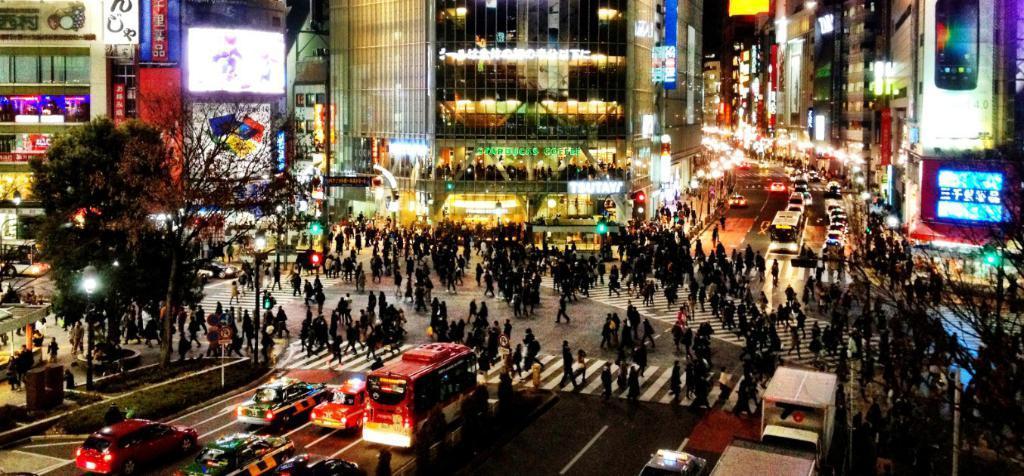How would you summarize this image in a sentence or two? Here in this picture we can see number of people standing and walking on the road and we can also see number of vehicles present and we can see buildings present, which are having hoardings on it and we can also see display screens present on the buildings and we can see plants and trees also present on the ground and we can also see light posts present. 